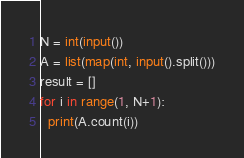<code> <loc_0><loc_0><loc_500><loc_500><_Python_>N = int(input())
A = list(map(int, input().split()))
result = []
for i in range(1, N+1):
  print(A.count(i))</code> 